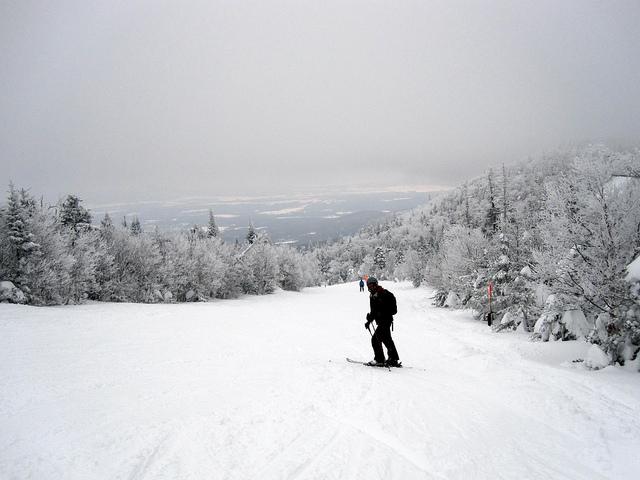Are the people going uphill?
Write a very short answer. No. What color are the flags marking the trail?
Write a very short answer. Red. What type of weather is this?
Answer briefly. Snowy. 